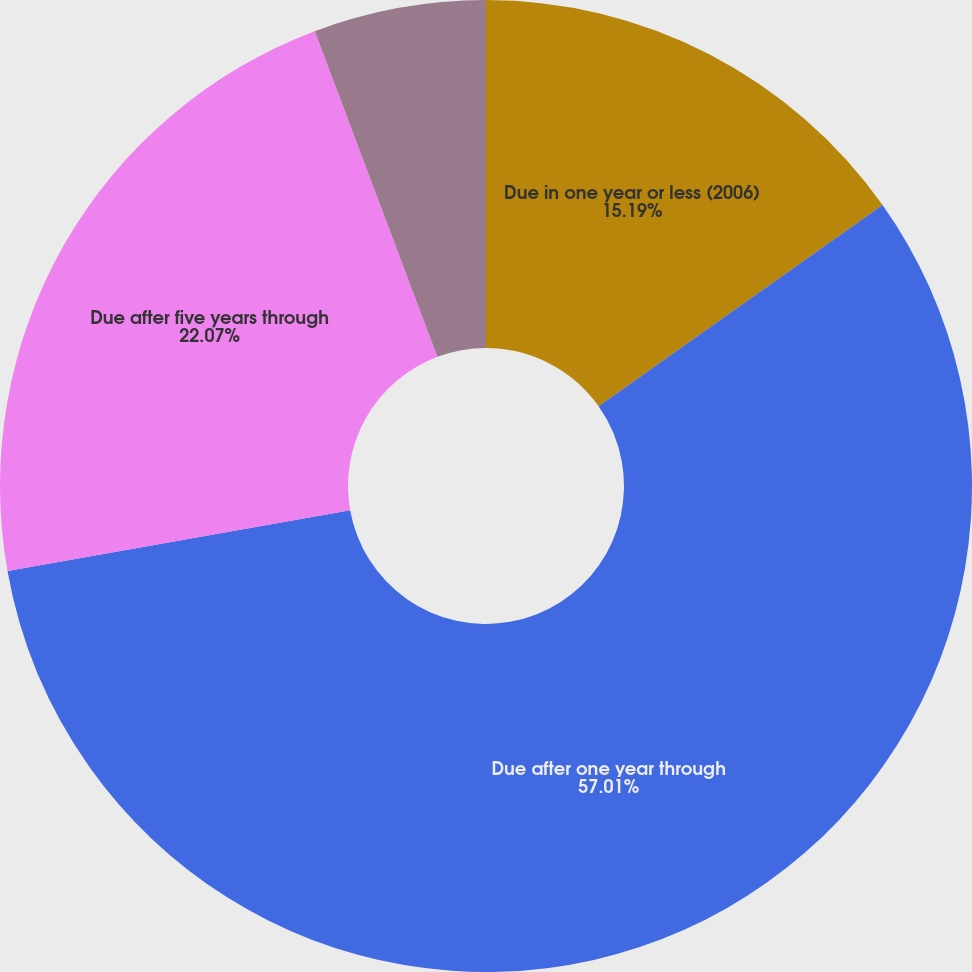Convert chart. <chart><loc_0><loc_0><loc_500><loc_500><pie_chart><fcel>Due in one year or less (2006)<fcel>Due after one year through<fcel>Due after five years through<fcel>Due after ten years (2017 and<nl><fcel>15.19%<fcel>57.01%<fcel>22.07%<fcel>5.73%<nl></chart> 